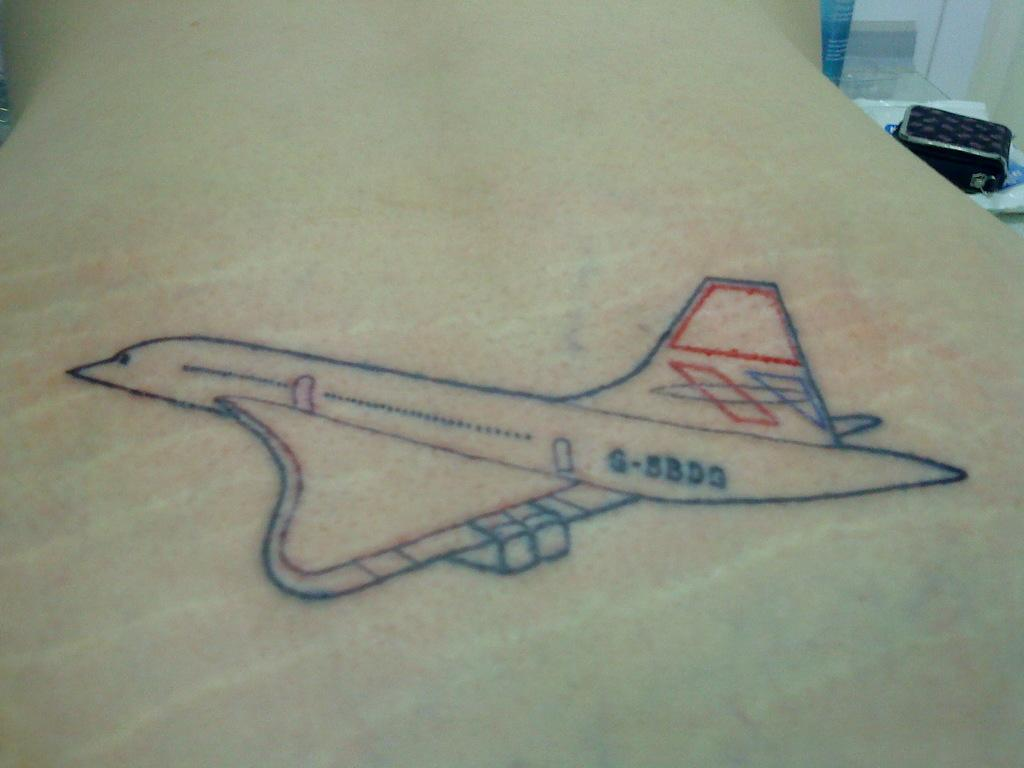<image>
Offer a succinct explanation of the picture presented. A tattoo of a airplane with the numbers G-5BDG 